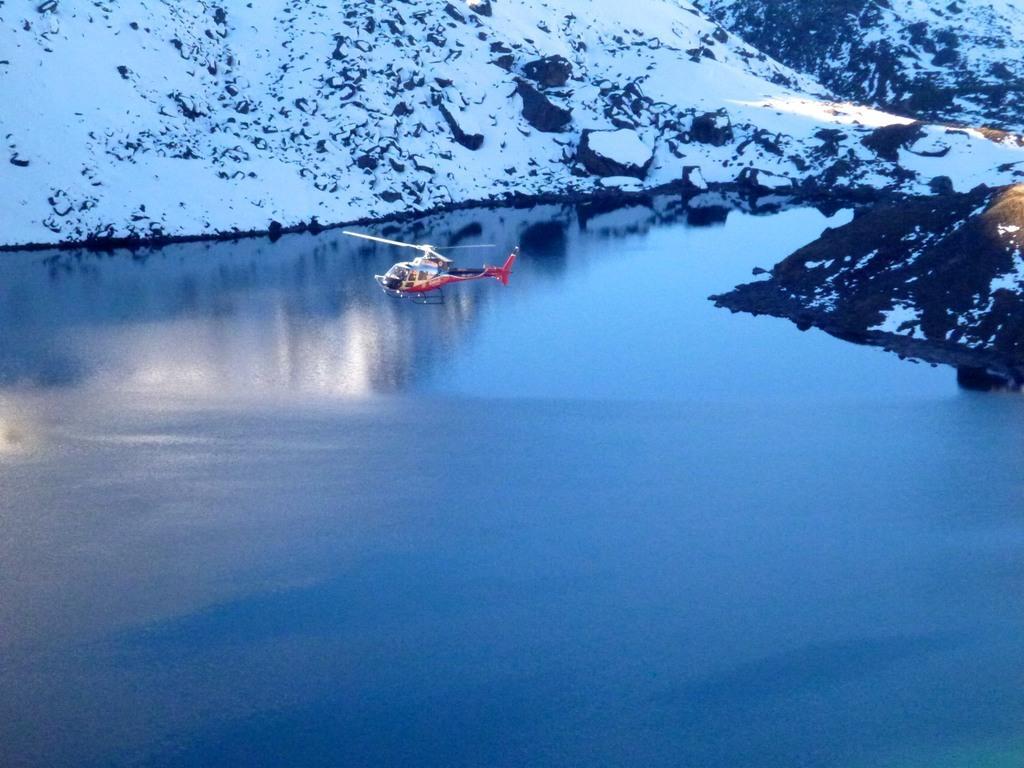Please provide a concise description of this image. In this picture I can see a helicopter flying above the water, and in the background there are snowy mountains. 